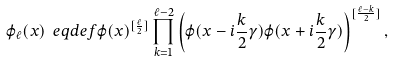Convert formula to latex. <formula><loc_0><loc_0><loc_500><loc_500>\varphi _ { \ell } ( x ) \ e q d e f \varphi ( x ) ^ { [ \frac { \ell } { 2 } ] } \prod _ { k = 1 } ^ { \ell - 2 } \left ( \varphi ( x - i \frac { k } { 2 } \gamma ) \varphi ( x + i \frac { k } { 2 } \gamma ) \right ) ^ { [ \frac { \ell - k } { 2 } ] } ,</formula> 